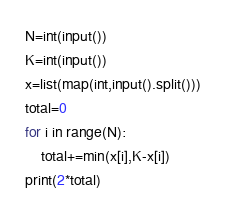<code> <loc_0><loc_0><loc_500><loc_500><_Python_>N=int(input())
K=int(input())
x=list(map(int,input().split()))
total=0
for i in range(N):
    total+=min(x[i],K-x[i])
print(2*total)</code> 